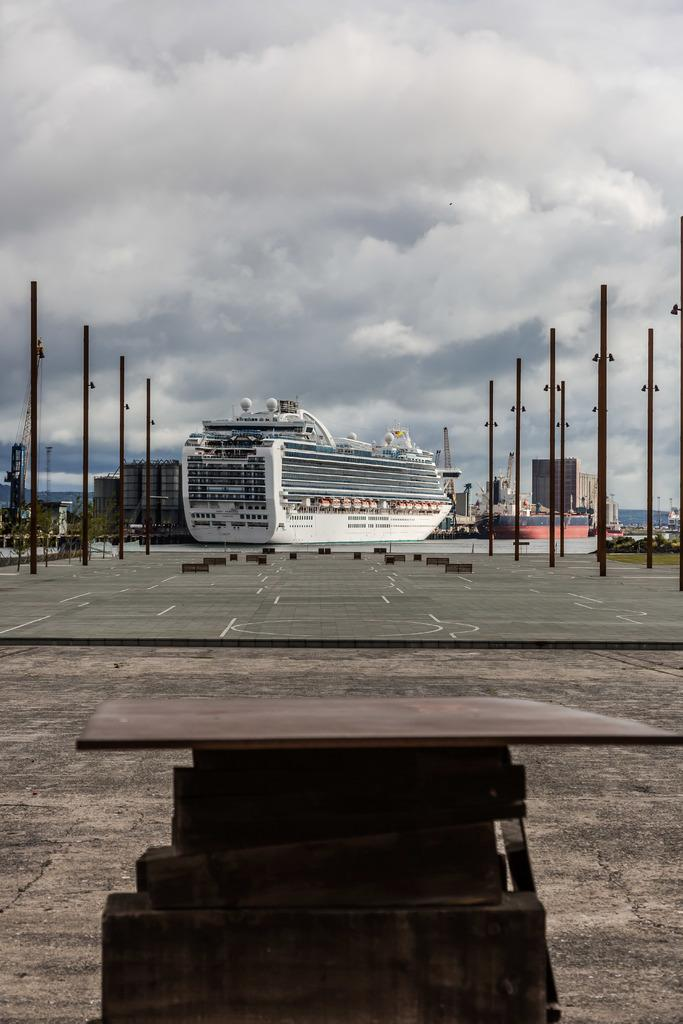What can be seen in the background of the image? In the background of the image, there are boats and the sky visible. What are the weather conditions like in the image? The presence of clouds in the background suggests that the weather might be partly cloudy. What is located in the center of the image? There is a road and poles in the center of the image. What is in the foreground of the image? There is a wooden object in the foreground of the image. How much dust can be seen on the boats in the image? There is no mention of dust in the image, and the boats are in the background, so it is not possible to determine the presence or amount of dust on them. What type of view can be seen from the boats in the image? There is no view from the boats in the image, as they are in the background and not the focus of the image. 